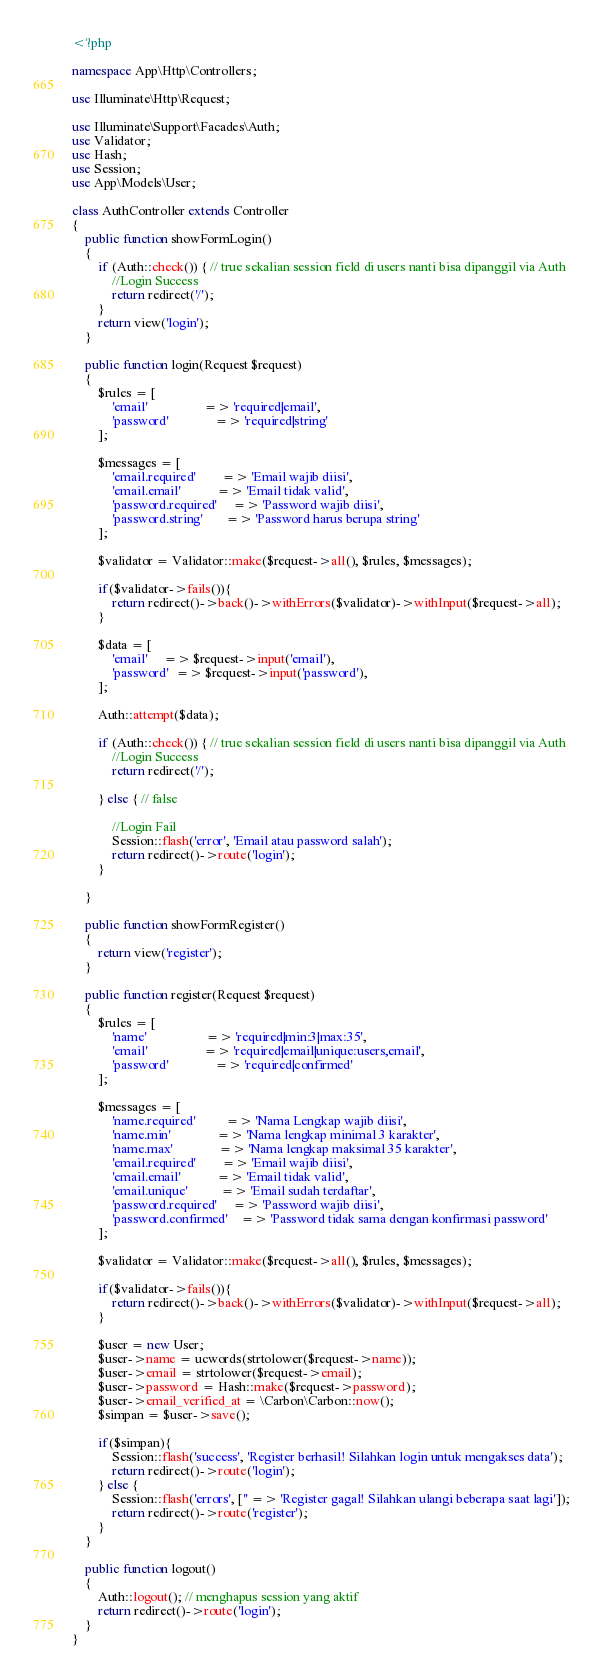<code> <loc_0><loc_0><loc_500><loc_500><_PHP_><?php

namespace App\Http\Controllers;

use Illuminate\Http\Request;
  
use Illuminate\Support\Facades\Auth;
use Validator;
use Hash;
use Session;
use App\Models\User;

class AuthController extends Controller
{
    public function showFormLogin()
    {
        if (Auth::check()) { // true sekalian session field di users nanti bisa dipanggil via Auth
            //Login Success
            return redirect('/');
        }
        return view('login');
    }
  
    public function login(Request $request)
    {
        $rules = [
            'email'                 => 'required|email',
            'password'              => 'required|string'
        ];
  
        $messages = [
            'email.required'        => 'Email wajib diisi',
            'email.email'           => 'Email tidak valid',
            'password.required'     => 'Password wajib diisi',
            'password.string'       => 'Password harus berupa string'
        ];
  
        $validator = Validator::make($request->all(), $rules, $messages);
  
        if($validator->fails()){
            return redirect()->back()->withErrors($validator)->withInput($request->all);
        }
  
        $data = [
            'email'     => $request->input('email'),
            'password'  => $request->input('password'),
        ];
  
        Auth::attempt($data);
  
        if (Auth::check()) { // true sekalian session field di users nanti bisa dipanggil via Auth
            //Login Success
            return redirect('/');
  
        } else { // false
  
            //Login Fail
            Session::flash('error', 'Email atau password salah');
            return redirect()->route('login');
        }
  
    }
  
    public function showFormRegister()
    {
        return view('register');
    }
  
    public function register(Request $request)
    {
        $rules = [
            'name'                  => 'required|min:3|max:35',
            'email'                 => 'required|email|unique:users,email',
            'password'              => 'required|confirmed'
        ];
  
        $messages = [
            'name.required'         => 'Nama Lengkap wajib diisi',
            'name.min'              => 'Nama lengkap minimal 3 karakter',
            'name.max'              => 'Nama lengkap maksimal 35 karakter',
            'email.required'        => 'Email wajib diisi',
            'email.email'           => 'Email tidak valid',
            'email.unique'          => 'Email sudah terdaftar',
            'password.required'     => 'Password wajib diisi',
            'password.confirmed'    => 'Password tidak sama dengan konfirmasi password'
        ];
  
        $validator = Validator::make($request->all(), $rules, $messages);
  
        if($validator->fails()){
            return redirect()->back()->withErrors($validator)->withInput($request->all);
        }
  
        $user = new User;
        $user->name = ucwords(strtolower($request->name));
        $user->email = strtolower($request->email);
        $user->password = Hash::make($request->password);
        $user->email_verified_at = \Carbon\Carbon::now();
        $simpan = $user->save();
  
        if($simpan){
            Session::flash('success', 'Register berhasil! Silahkan login untuk mengakses data');
            return redirect()->route('login');
        } else {
            Session::flash('errors', ['' => 'Register gagal! Silahkan ulangi beberapa saat lagi']);
            return redirect()->route('register');
        }
    }
  
    public function logout()
    {
        Auth::logout(); // menghapus session yang aktif
        return redirect()->route('login');
    }
}
</code> 